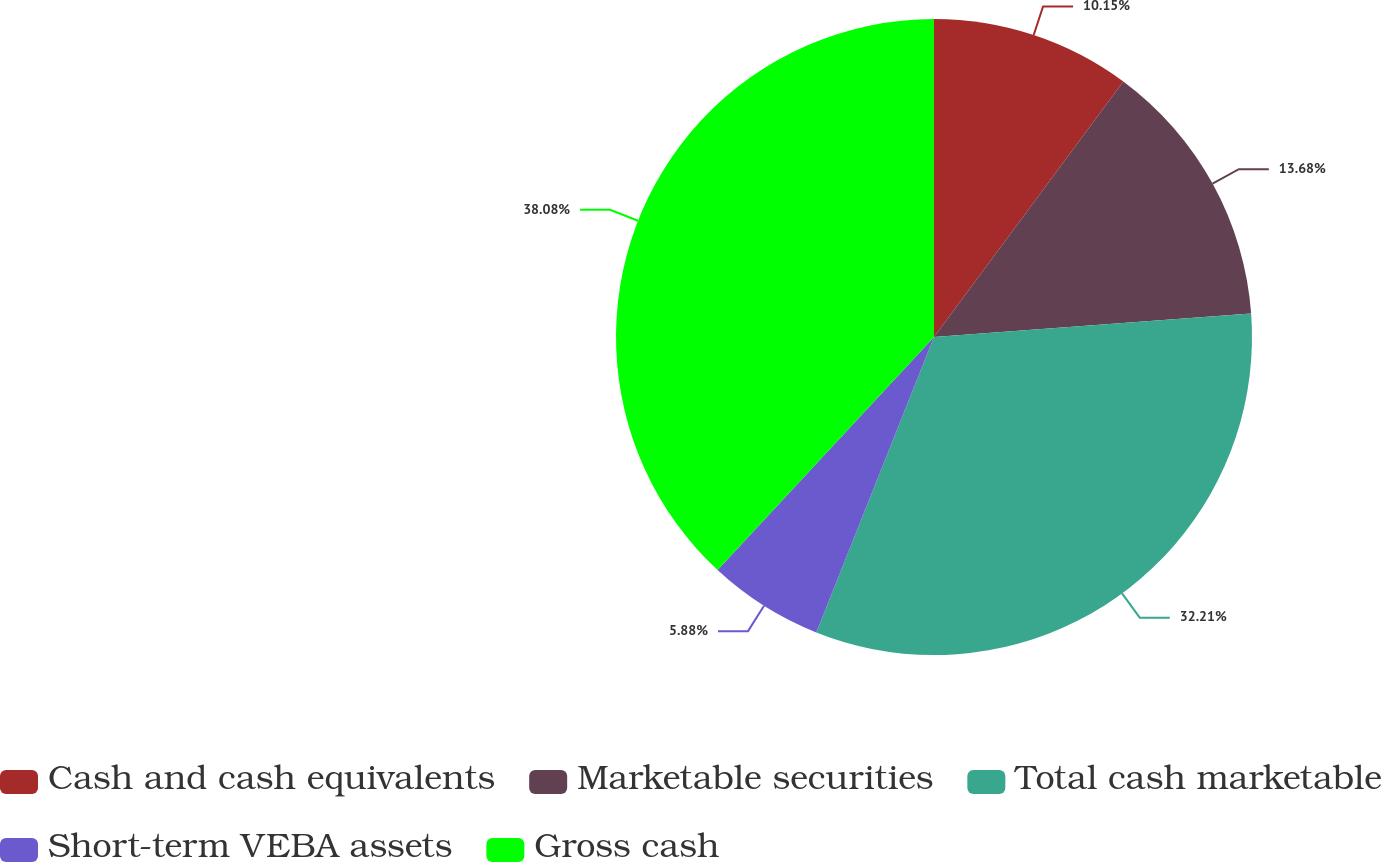<chart> <loc_0><loc_0><loc_500><loc_500><pie_chart><fcel>Cash and cash equivalents<fcel>Marketable securities<fcel>Total cash marketable<fcel>Short-term VEBA assets<fcel>Gross cash<nl><fcel>10.15%<fcel>13.68%<fcel>32.21%<fcel>5.88%<fcel>38.09%<nl></chart> 